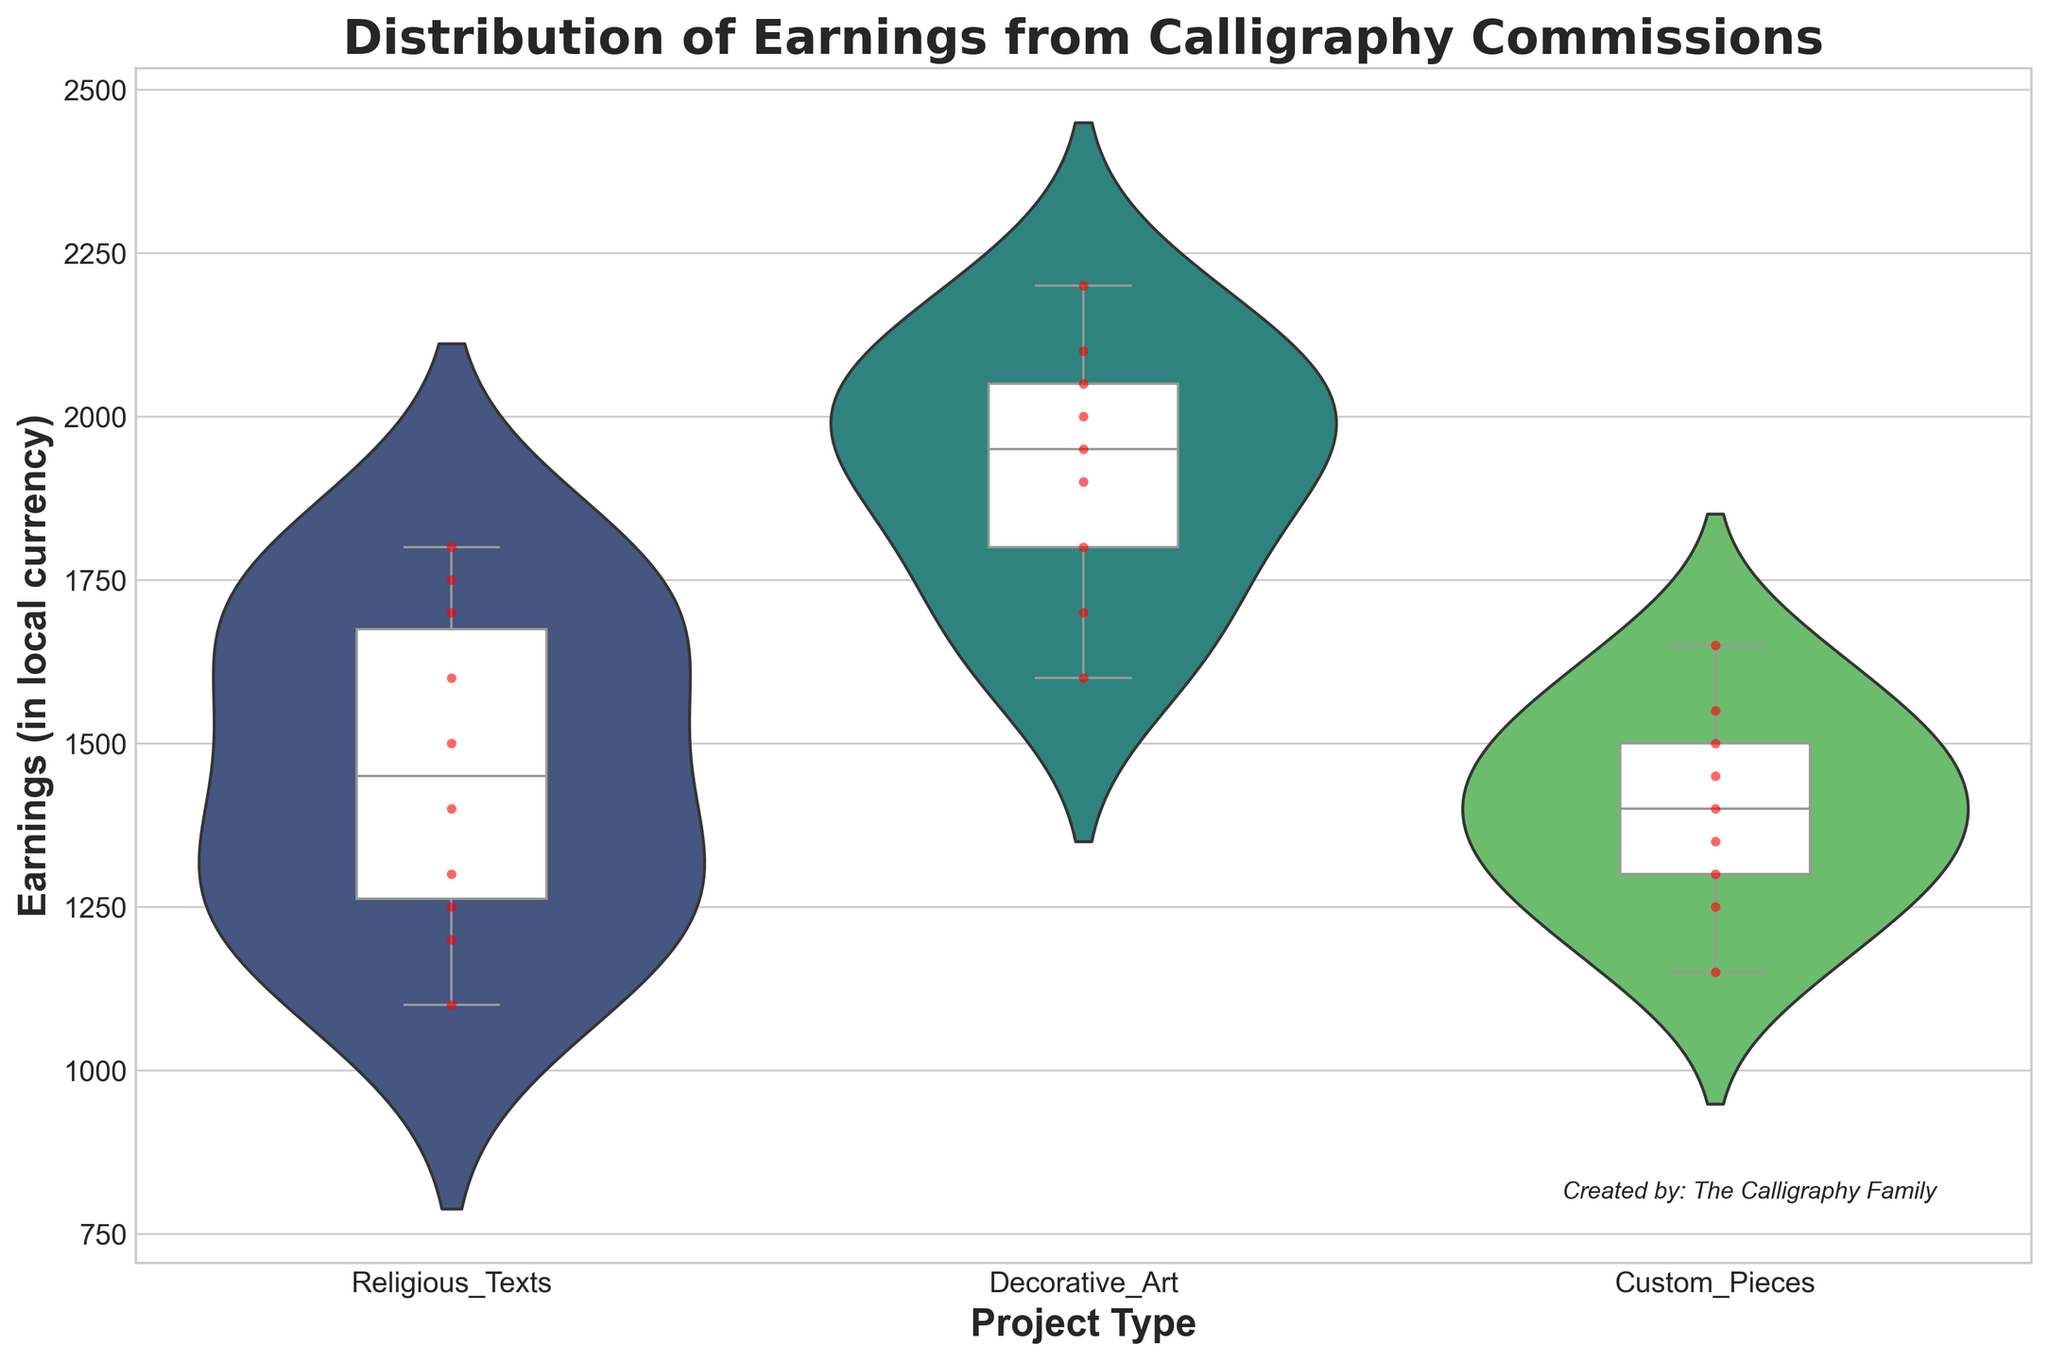Which project type has the highest median earnings? By examining the box plot overlay within each violin plot, the median (the line inside each box) is highest for the Decorative Art project type.
Answer: Decorative Art What is the range of earnings for Religious Texts projects? The range of earnings is determined by examining the extremes of the violin plot: the lowest point is 1100 and the highest is 1800.
Answer: 1100-1800 How do the earnings distributions compare between Decorative Art and Custom Pieces? The violin plot and box plot show that the distribution for Decorative Art is higher and more spread out than Custom Pieces. The median also lies higher for Decorative Art.
Answer: Decorative Art has higher and more spread out earnings How does Ahmed’s earnings from Custom Pieces compare to Amina’s earnings from the same project type? Examining the swarm plot dots and comparing Ahmed’s and Amina’s earnings distribution, Ahmed has lower earnings (1300 and 1400) versus Amina (1450 and 1500).
Answer: Amina earns more than Ahmed What is the interquartile range (IQR) for earnings from Religious Texts projects? The IQR is determined by the height of the box: the 1st quartile is at 1250 and the 3rd at 1700, making the IQR 1700 - 1250 = 450.
Answer: 450 Which family member shows the most variation in earnings across all project types? By inspecting the swarm plot and observing spread patterns, Omar has wide variations in his earnings across all project types.
Answer: Omar Are there any outliers in the earnings for any of the project types? If so, which types and where? Analyzing the box plots for whiskers extending beyond typical ranges or lone dots, there are no clear outliers shown in any of the project types.
Answer: No outliers What is the difference in median earnings between Religious Texts and Custom Pieces projects? Looking at the medians (lines in boxes) of both: Religious Texts median is approximately 1350, Custom Pieces is approximately 1400. The difference is 1400 - 1350 = 50.
Answer: 50 